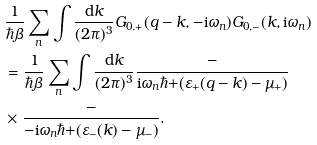<formula> <loc_0><loc_0><loc_500><loc_500>& \frac { 1 } { \hbar { \beta } } \sum _ { n } \int \frac { \text {d} k } { ( 2 \pi ) ^ { 3 } } G _ { 0 , + } ( q - k , - \text {i} \omega _ { n } ) G _ { 0 , - } ( k , \text {i} \omega _ { n } ) \\ & = \frac { 1 } { \hbar { \beta } } \sum _ { n } \int \frac { \text {d} k } { ( 2 \pi ) ^ { 3 } } \frac { - } { \text {i} \omega _ { n } \hbar { + } ( \varepsilon _ { + } ( q - k ) - \mu _ { + } ) } \\ & \times \frac { - } { - \text {i} \omega _ { n } \hbar { + } ( \varepsilon _ { - } ( k ) - \mu _ { - } ) } .</formula> 